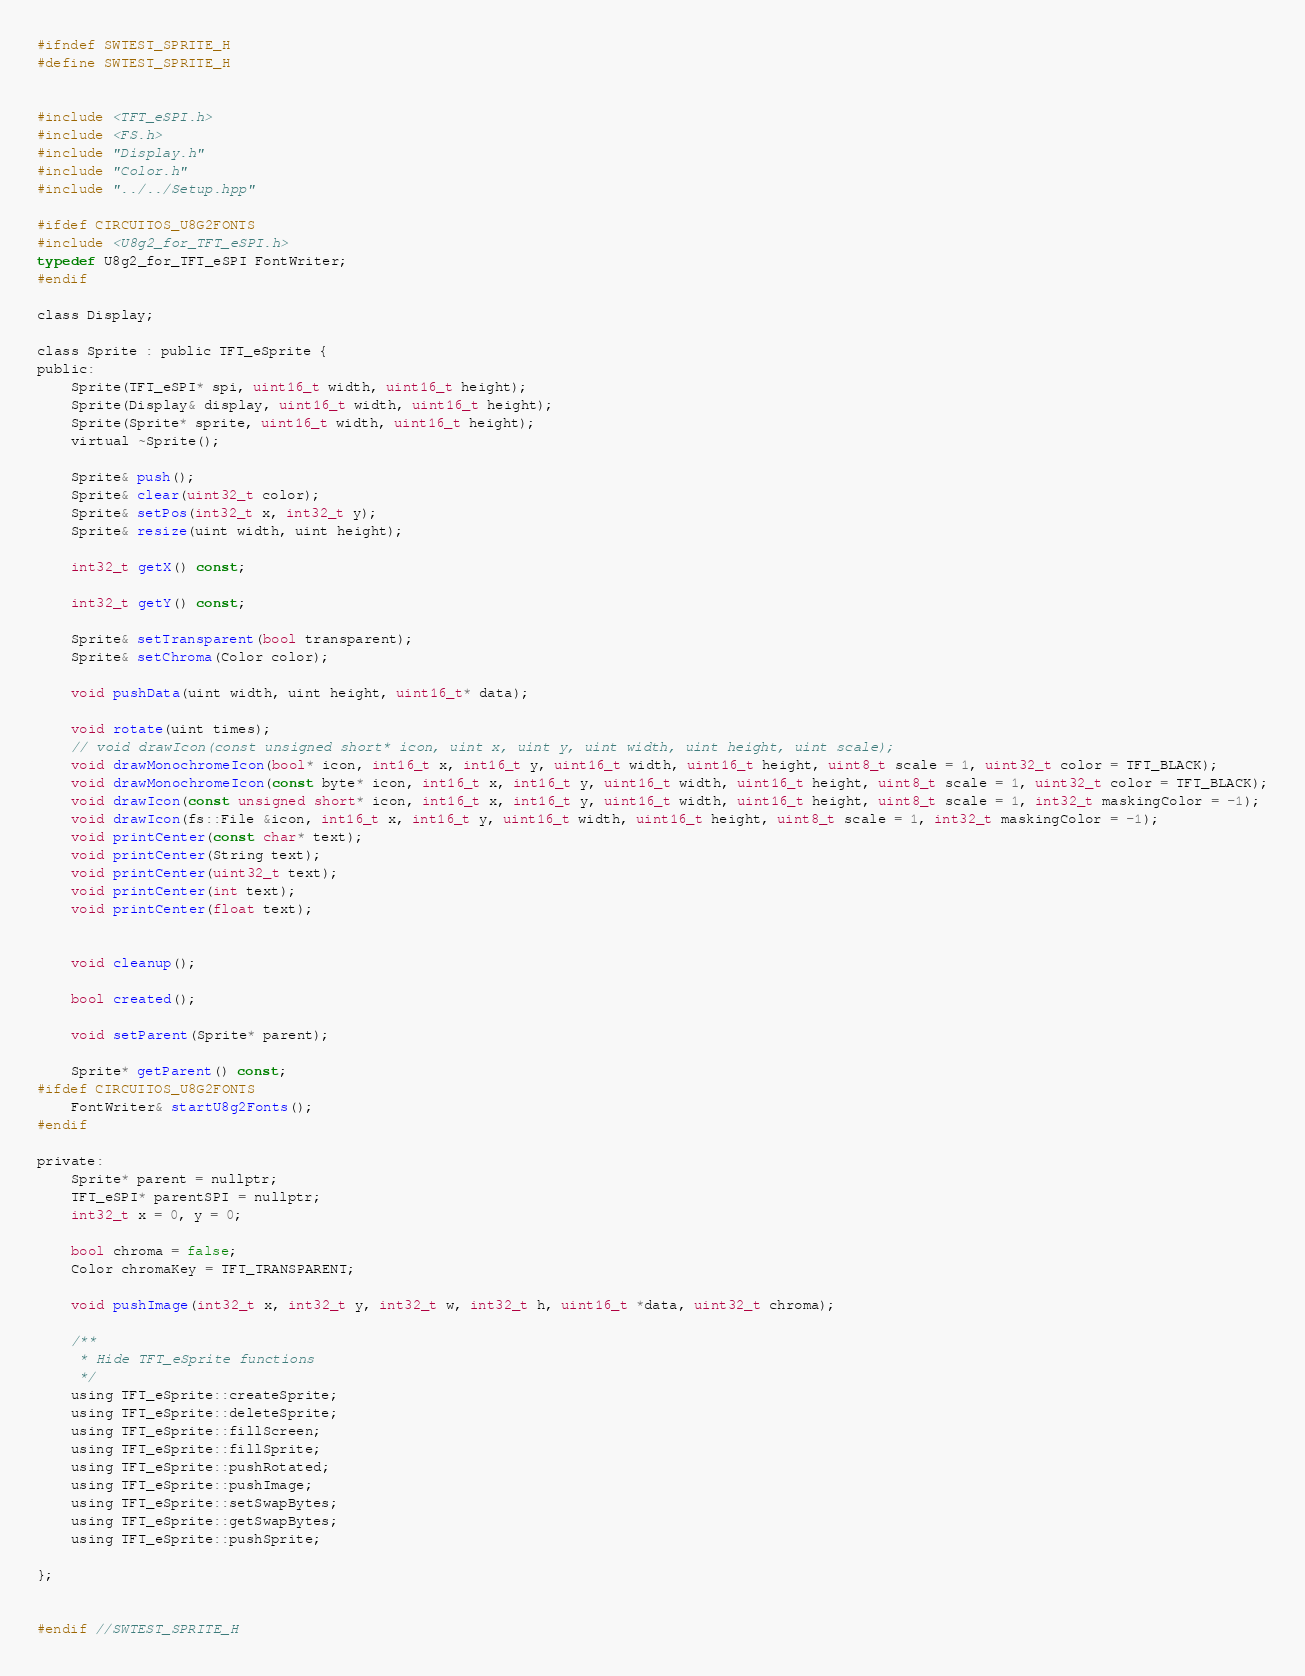<code> <loc_0><loc_0><loc_500><loc_500><_C_>#ifndef SWTEST_SPRITE_H
#define SWTEST_SPRITE_H


#include <TFT_eSPI.h>
#include <FS.h>
#include "Display.h"
#include "Color.h"
#include "../../Setup.hpp"

#ifdef CIRCUITOS_U8G2FONTS
#include <U8g2_for_TFT_eSPI.h>
typedef U8g2_for_TFT_eSPI FontWriter;
#endif

class Display;

class Sprite : public TFT_eSprite {
public:
	Sprite(TFT_eSPI* spi, uint16_t width, uint16_t height);
	Sprite(Display& display, uint16_t width, uint16_t height);
	Sprite(Sprite* sprite, uint16_t width, uint16_t height);
	virtual ~Sprite();

	Sprite& push();
	Sprite& clear(uint32_t color);
	Sprite& setPos(int32_t x, int32_t y);
	Sprite& resize(uint width, uint height);

	int32_t getX() const;

	int32_t getY() const;

	Sprite& setTransparent(bool transparent);
	Sprite& setChroma(Color color);

	void pushData(uint width, uint height, uint16_t* data);

	void rotate(uint times);
	// void drawIcon(const unsigned short* icon, uint x, uint y, uint width, uint height, uint scale);
	void drawMonochromeIcon(bool* icon, int16_t x, int16_t y, uint16_t width, uint16_t height, uint8_t scale = 1, uint32_t color = TFT_BLACK);
	void drawMonochromeIcon(const byte* icon, int16_t x, int16_t y, uint16_t width, uint16_t height, uint8_t scale = 1, uint32_t color = TFT_BLACK);
	void drawIcon(const unsigned short* icon, int16_t x, int16_t y, uint16_t width, uint16_t height, uint8_t scale = 1, int32_t maskingColor = -1);
	void drawIcon(fs::File &icon, int16_t x, int16_t y, uint16_t width, uint16_t height, uint8_t scale = 1, int32_t maskingColor = -1);
	void printCenter(const char* text);
	void printCenter(String text);
	void printCenter(uint32_t text);
	void printCenter(int text);
	void printCenter(float text);


	void cleanup();

	bool created();

	void setParent(Sprite* parent);

	Sprite* getParent() const;
#ifdef CIRCUITOS_U8G2FONTS
	FontWriter& startU8g2Fonts();
#endif

private:
	Sprite* parent = nullptr;
	TFT_eSPI* parentSPI = nullptr;
	int32_t x = 0, y = 0;

	bool chroma = false;
	Color chromaKey = TFT_TRANSPARENT;

	void pushImage(int32_t x, int32_t y, int32_t w, int32_t h, uint16_t *data, uint32_t chroma);

	/**
	 * Hide TFT_eSprite functions
	 */
	using TFT_eSprite::createSprite;
	using TFT_eSprite::deleteSprite;
	using TFT_eSprite::fillScreen;
	using TFT_eSprite::fillSprite;
	using TFT_eSprite::pushRotated;
	using TFT_eSprite::pushImage;
	using TFT_eSprite::setSwapBytes;
	using TFT_eSprite::getSwapBytes;
	using TFT_eSprite::pushSprite;

};


#endif //SWTEST_SPRITE_H
</code> 